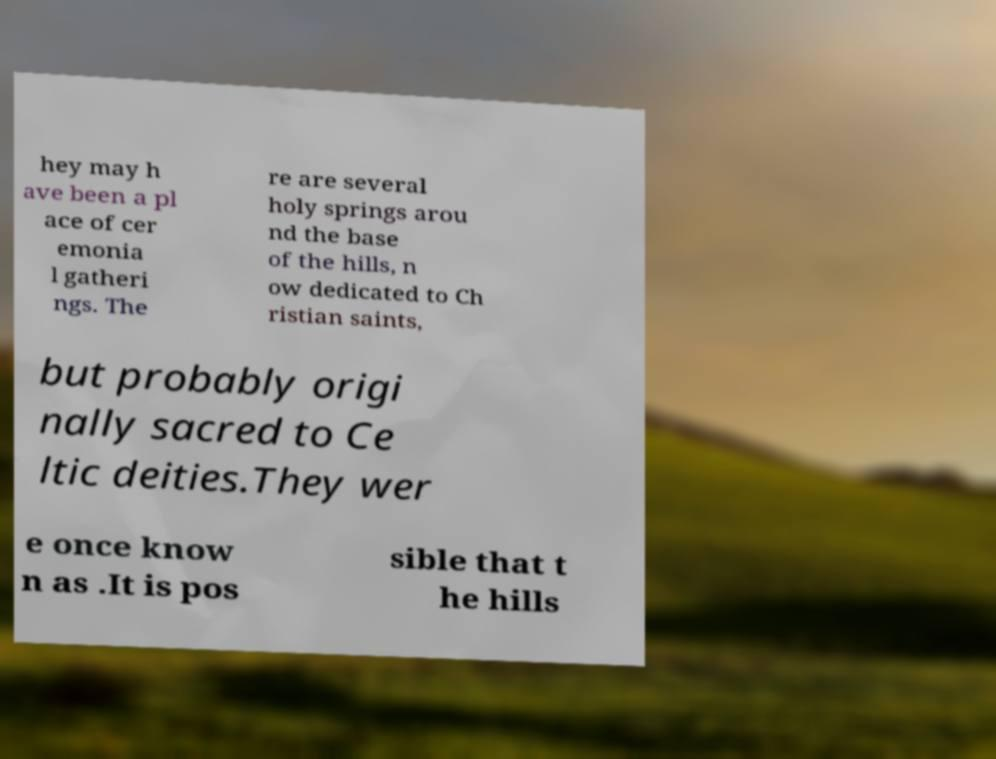Could you assist in decoding the text presented in this image and type it out clearly? hey may h ave been a pl ace of cer emonia l gatheri ngs. The re are several holy springs arou nd the base of the hills, n ow dedicated to Ch ristian saints, but probably origi nally sacred to Ce ltic deities.They wer e once know n as .It is pos sible that t he hills 